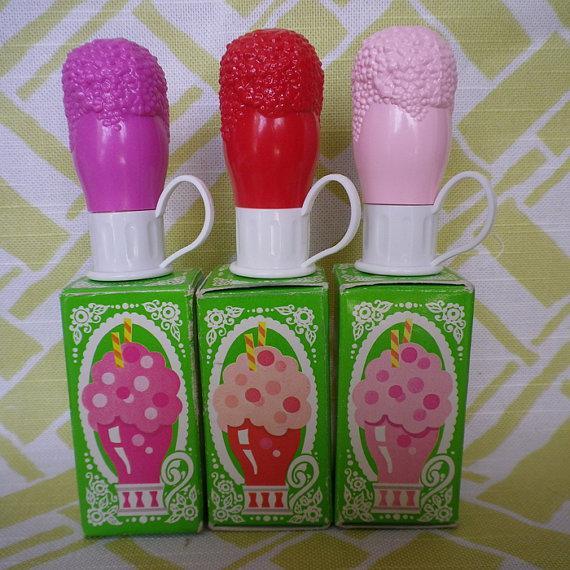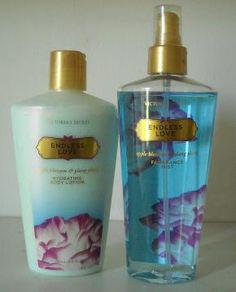The first image is the image on the left, the second image is the image on the right. For the images displayed, is the sentence "There are five lotions/fragrances in total." factually correct? Answer yes or no. Yes. The first image is the image on the left, the second image is the image on the right. Considering the images on both sides, is "The images contain no more than three beauty products." valid? Answer yes or no. Yes. 